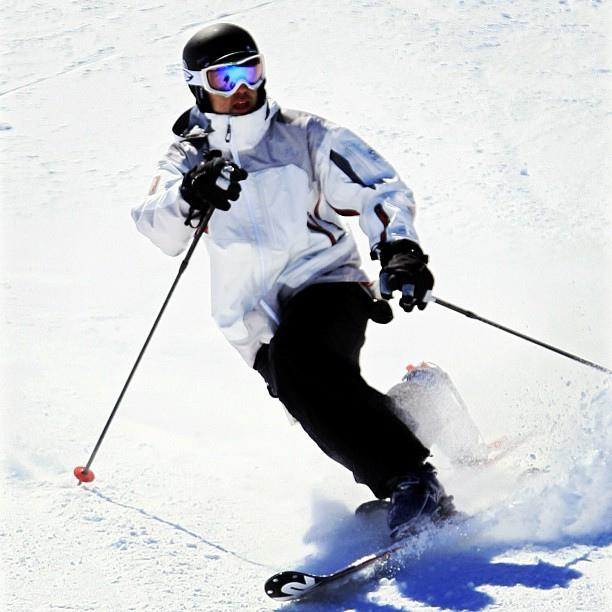What sport is happening here?
Concise answer only. Skiing. What color is the coat?
Answer briefly. White. Is this person a beginner?
Write a very short answer. No. 